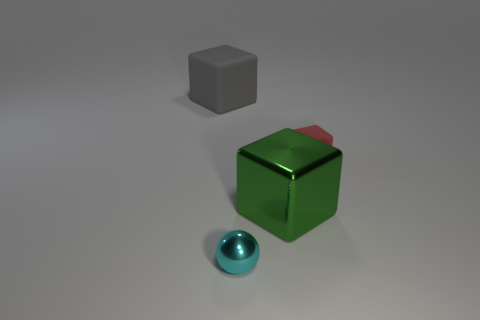How many red rubber objects are the same shape as the large gray rubber object?
Your response must be concise. 1. What size is the gray cube that is made of the same material as the small red cube?
Provide a succinct answer. Large. Is the sphere the same size as the shiny block?
Give a very brief answer. No. Is there a tiny red metal cylinder?
Your answer should be very brief. No. There is a matte thing that is behind the rubber object to the right of the large thing to the left of the large metallic block; what size is it?
Keep it short and to the point. Large. How many small balls are the same material as the big green cube?
Your answer should be very brief. 1. How many red objects are the same size as the cyan object?
Give a very brief answer. 1. There is a big object that is behind the rubber thing right of the big cube to the right of the tiny shiny sphere; what is it made of?
Keep it short and to the point. Rubber. How many things are tiny red rubber cubes or tiny metal things?
Your answer should be very brief. 2. There is a cyan metallic thing; what shape is it?
Keep it short and to the point. Sphere. 